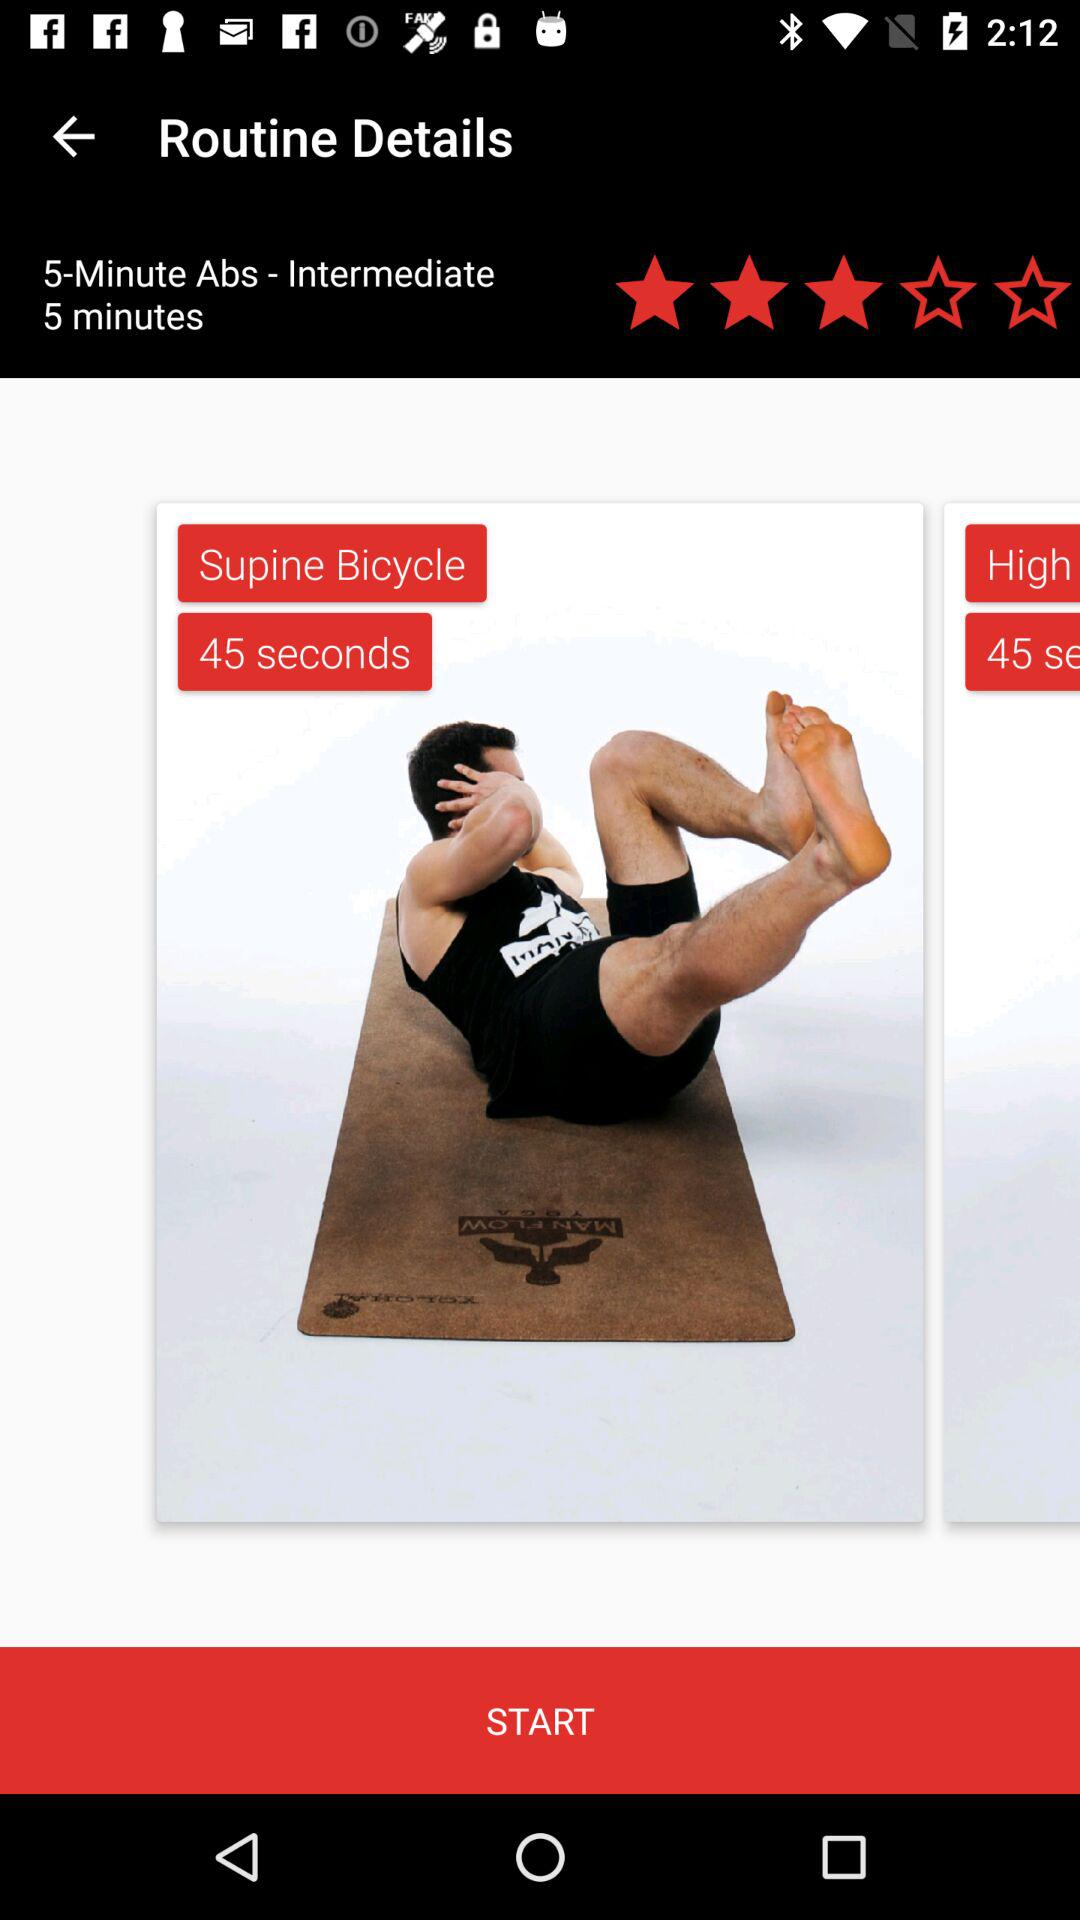What is the time duration for "Supine Bicycle"? The time duration is 45 seconds. 